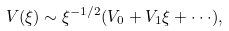Convert formula to latex. <formula><loc_0><loc_0><loc_500><loc_500>V ( \xi ) \sim \xi ^ { - 1 / 2 } ( V _ { 0 } + V _ { 1 } \xi + \cdot \cdot \cdot ) ,</formula> 